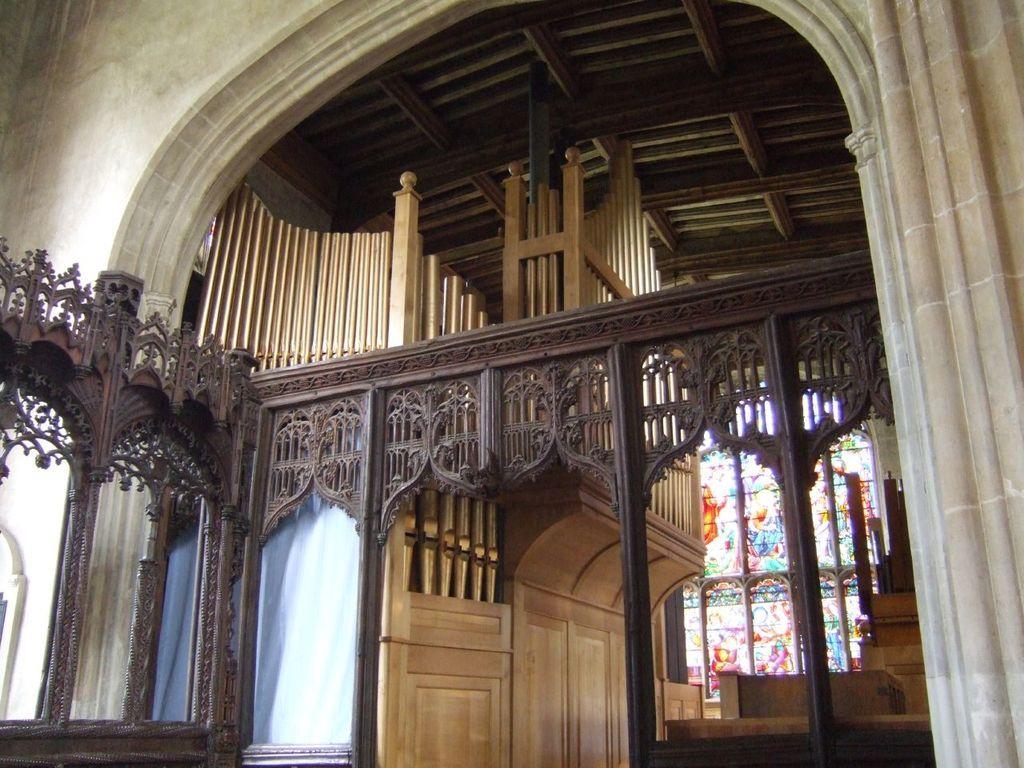In one or two sentences, can you explain what this image depicts? In this picture I can observe interior view of a building. In the middle of the picture I can observe design which is made up of wood. In the background I can observe stained glass. 